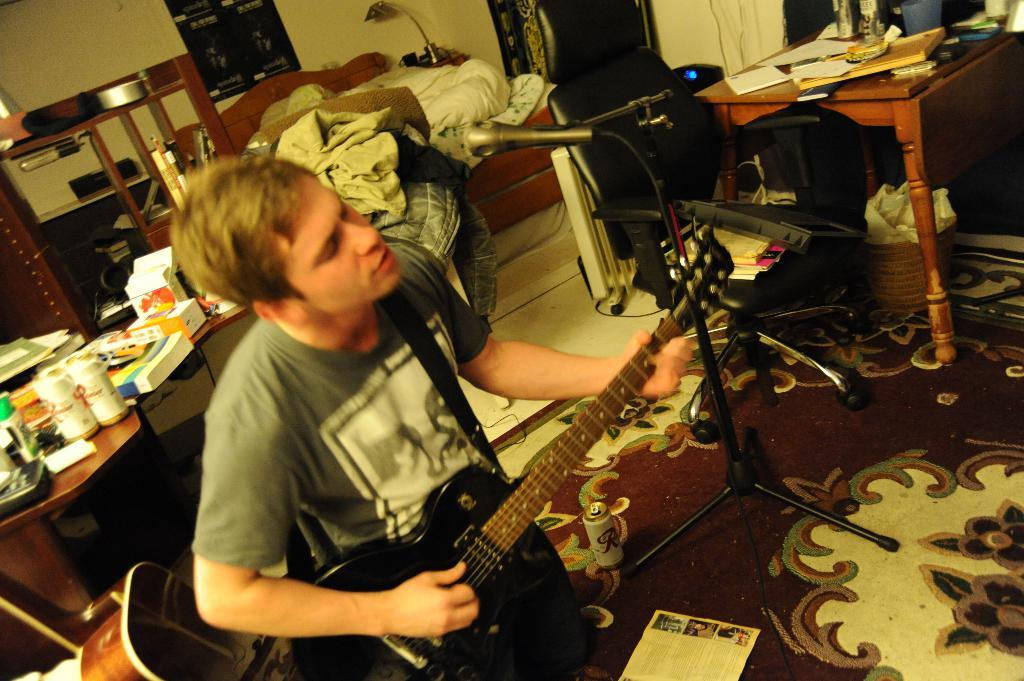What is the person in the image doing? The person is playing guitar and singing in front of a mic. What can be seen on either side of the person? There are tables on either side of the person. What is on the tables? There are objects on the tables. What is visible in the background of the image? There is a bed in the background of the image. What type of tank is visible in the image? There is no tank present in the image. How does the person in the image self-identify? The image does not provide information about the person's self-identity. 